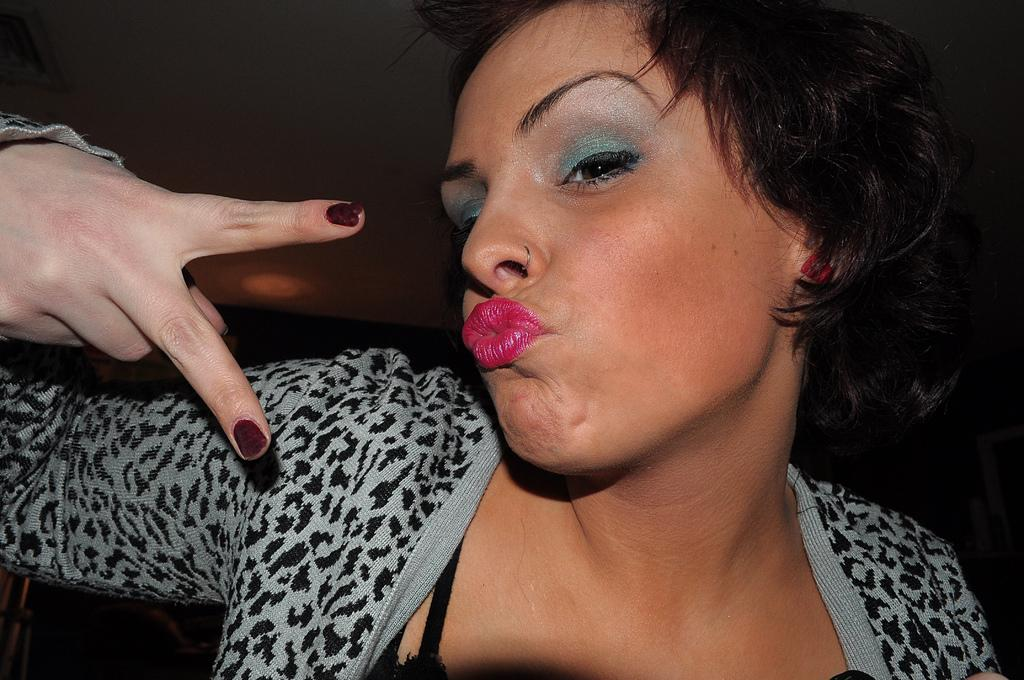Who is the main subject in the image? There is a woman in the image. What is the woman wearing? The woman is wearing a white and black color dress. How would you describe the lighting in the image? The background of the image is a bit dark. What type of blade can be seen in the woman's hand in the image? There is no blade present in the woman's hand or in the image. 